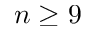Convert formula to latex. <formula><loc_0><loc_0><loc_500><loc_500>n \geq 9</formula> 